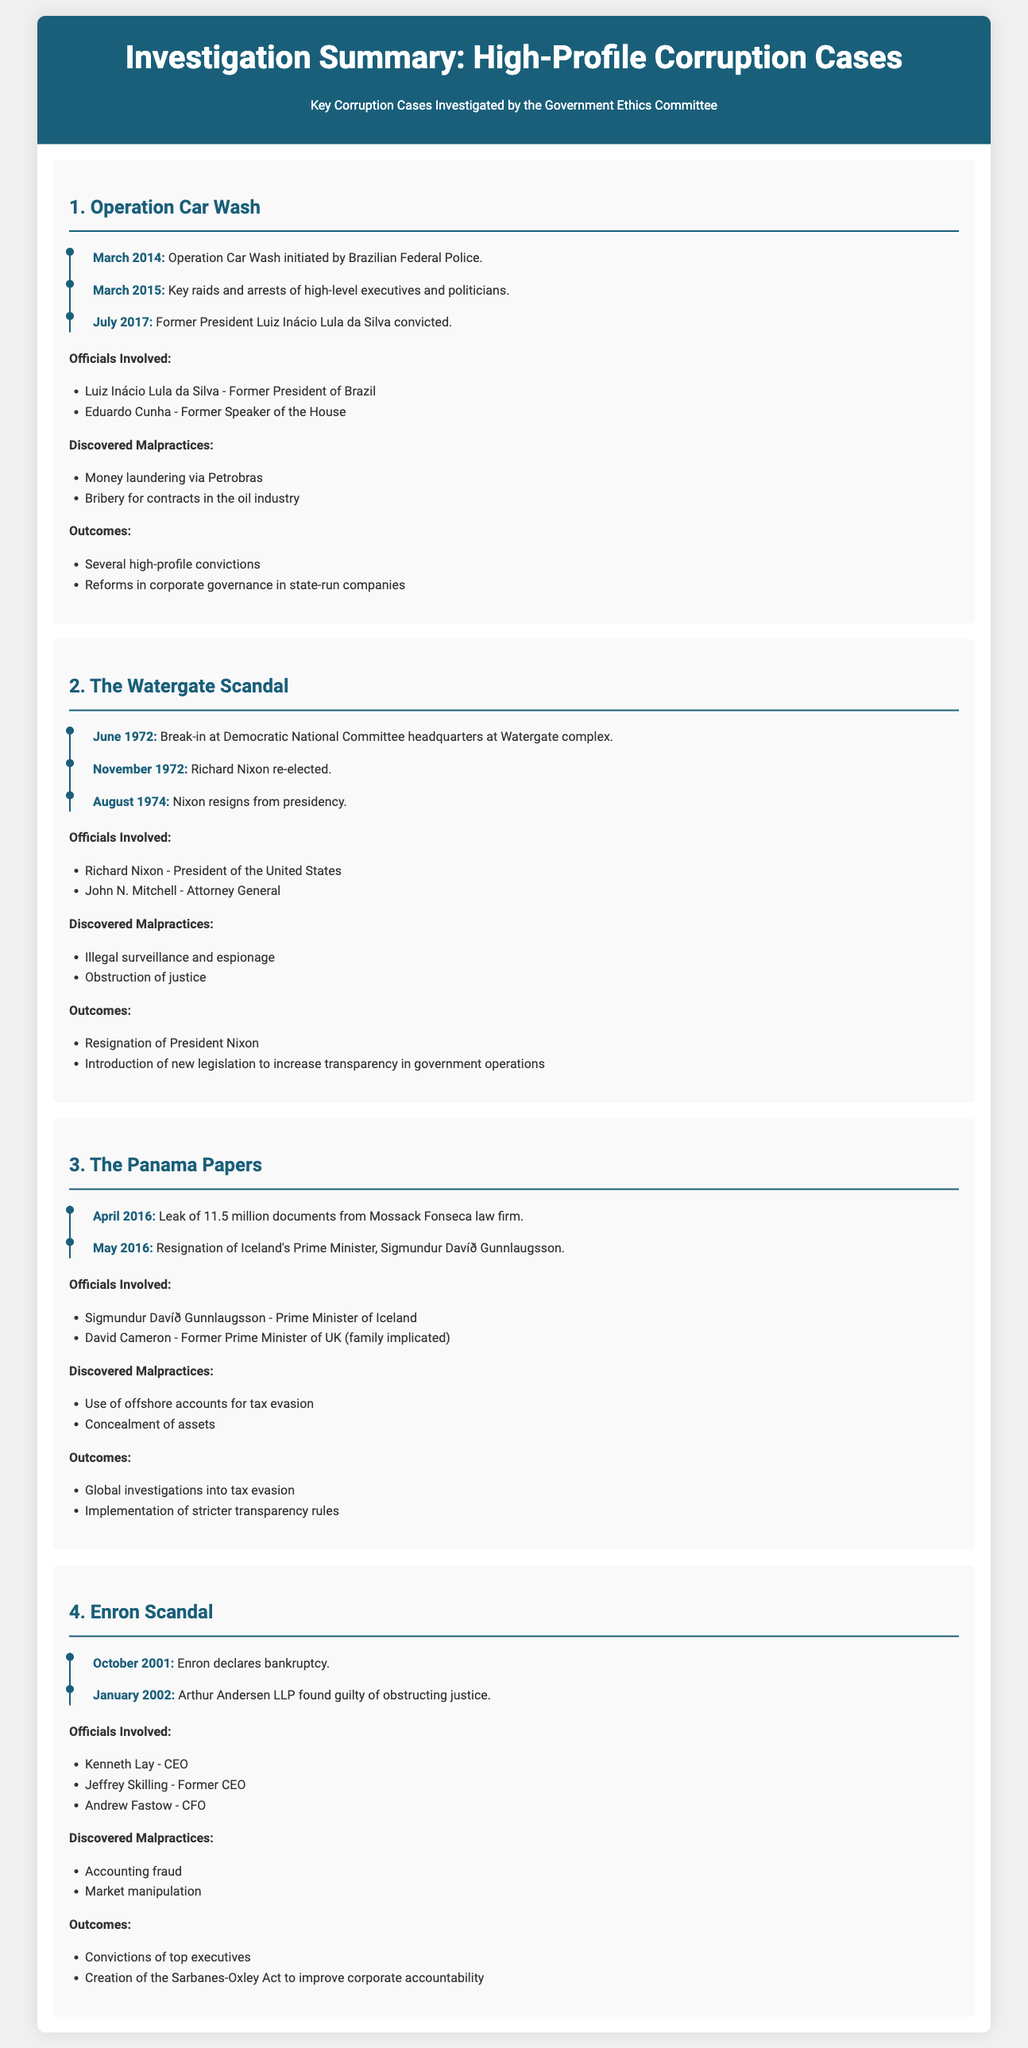What is the initiation date of Operation Car Wash? The document states that Operation Car Wash was initiated by the Brazilian Federal Police in March 2014.
Answer: March 2014 Who was the former President convicted in Operation Car Wash? The document lists Luiz Inácio Lula da Silva as the former President convicted in this case.
Answer: Luiz Inácio Lula da Silva What legislation was created as a result of the Enron Scandal? The document indicates that the Sarbanes-Oxley Act was created to improve corporate accountability after the scandal.
Answer: Sarbanes-Oxley Act Which official resigned due to the Panama Papers? According to the document, Sigmundur Davíð Gunnlaugsson resigned following the leak of the Panama Papers.
Answer: Sigmundur Davíð Gunnlaugsson What type of malpractices were discovered in the Watergate Scandal? The document mentions that illegal surveillance and obstruction of justice were the malpractices discovered.
Answer: Illegal surveillance and obstruction of justice How many major corruption cases are summarized in the document? The document provides summaries for four major corruption cases.
Answer: Four What was the outcome of the Watergate Scandal? The document states that the outcome included the resignation of President Nixon.
Answer: Resignation of President Nixon What year did the Enron bankruptcy occur? The document confirms that Enron declared bankruptcy in October 2001.
Answer: October 2001 